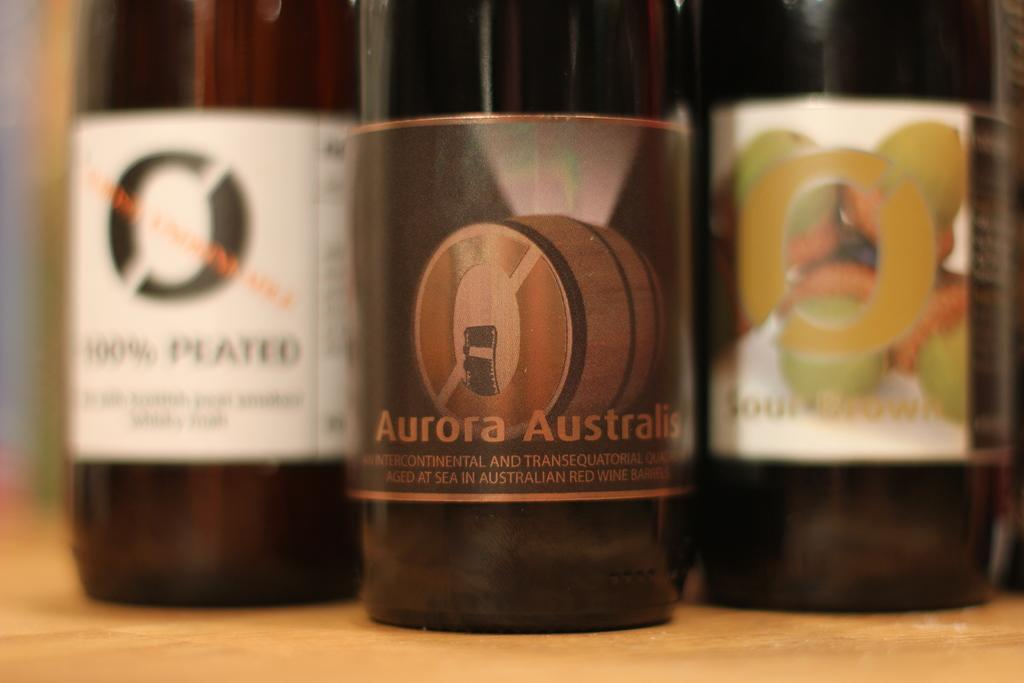<image>
Render a clear and concise summary of the photo. three bottles on a table, front bottle is labeled aurora australis 